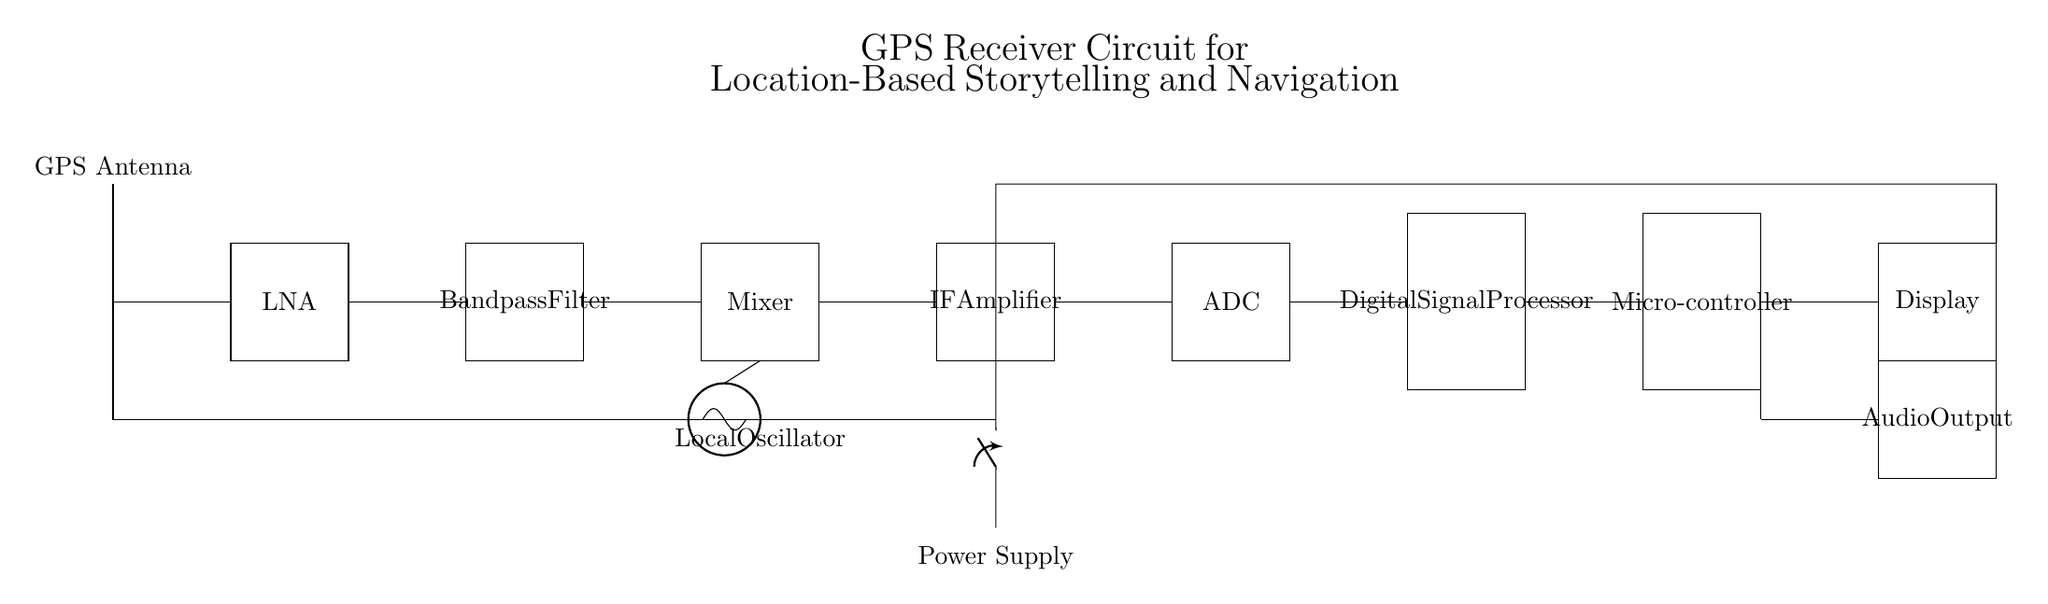What component captures the GPS signal? The GPS antenna is at the top of the circuit diagram and is responsible for capturing the GPS signal.
Answer: GPS Antenna What follows the Low Noise Amplifier in the signal path? After the Low Noise Amplifier, the signal goes to the Bandpass Filter, as indicated by the connections in the diagram.
Answer: Bandpass Filter What does the Digital Signal Processor do in the circuit? The Digital Signal Processor processes the signals received from the ADC before they are sent to the Microcontroller and ultimately displayed or outputted as audio.
Answer: Signal Processing How many components are present in the circuit? By counting each individual component within the circuit diagram, including the antenna, amplifiers, mixer, etc., there are ten components.
Answer: Ten What type of oscillator is included in the circuit? The diagram shows a Local Oscillator, which is used in communication circuits to convert frequencies for processing.
Answer: Local Oscillator Which component generates audio output? The Audio Output component, located below the Microcontroller, is responsible for generating audio output from the processed GPS data.
Answer: Audio Output 